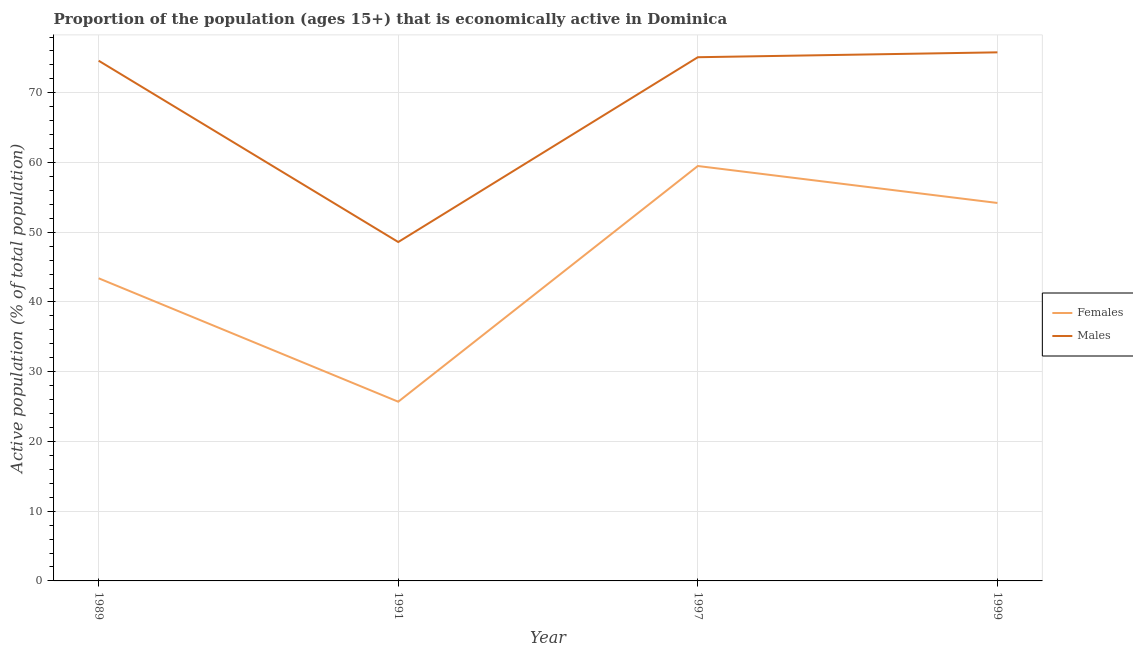How many different coloured lines are there?
Keep it short and to the point. 2. Is the number of lines equal to the number of legend labels?
Give a very brief answer. Yes. What is the percentage of economically active male population in 1999?
Your answer should be compact. 75.8. Across all years, what is the maximum percentage of economically active male population?
Provide a succinct answer. 75.8. Across all years, what is the minimum percentage of economically active male population?
Your response must be concise. 48.6. In which year was the percentage of economically active female population maximum?
Your answer should be compact. 1997. In which year was the percentage of economically active female population minimum?
Your answer should be compact. 1991. What is the total percentage of economically active male population in the graph?
Give a very brief answer. 274.1. What is the difference between the percentage of economically active female population in 1989 and that in 1991?
Provide a short and direct response. 17.7. What is the difference between the percentage of economically active male population in 1991 and the percentage of economically active female population in 1989?
Make the answer very short. 5.2. What is the average percentage of economically active female population per year?
Provide a short and direct response. 45.7. In the year 1989, what is the difference between the percentage of economically active female population and percentage of economically active male population?
Your response must be concise. -31.2. In how many years, is the percentage of economically active female population greater than 70 %?
Keep it short and to the point. 0. What is the ratio of the percentage of economically active male population in 1989 to that in 1991?
Your answer should be very brief. 1.53. What is the difference between the highest and the second highest percentage of economically active female population?
Give a very brief answer. 5.3. What is the difference between the highest and the lowest percentage of economically active female population?
Give a very brief answer. 33.8. Is the sum of the percentage of economically active female population in 1991 and 1997 greater than the maximum percentage of economically active male population across all years?
Provide a succinct answer. Yes. Does the percentage of economically active female population monotonically increase over the years?
Provide a succinct answer. No. How many lines are there?
Make the answer very short. 2. What is the difference between two consecutive major ticks on the Y-axis?
Your response must be concise. 10. Does the graph contain any zero values?
Provide a succinct answer. No. How are the legend labels stacked?
Provide a succinct answer. Vertical. What is the title of the graph?
Offer a terse response. Proportion of the population (ages 15+) that is economically active in Dominica. Does "Infant" appear as one of the legend labels in the graph?
Offer a terse response. No. What is the label or title of the Y-axis?
Your answer should be compact. Active population (% of total population). What is the Active population (% of total population) in Females in 1989?
Provide a succinct answer. 43.4. What is the Active population (% of total population) in Males in 1989?
Ensure brevity in your answer.  74.6. What is the Active population (% of total population) in Females in 1991?
Provide a succinct answer. 25.7. What is the Active population (% of total population) of Males in 1991?
Your answer should be very brief. 48.6. What is the Active population (% of total population) in Females in 1997?
Give a very brief answer. 59.5. What is the Active population (% of total population) of Males in 1997?
Your answer should be very brief. 75.1. What is the Active population (% of total population) in Females in 1999?
Your answer should be compact. 54.2. What is the Active population (% of total population) in Males in 1999?
Provide a succinct answer. 75.8. Across all years, what is the maximum Active population (% of total population) in Females?
Give a very brief answer. 59.5. Across all years, what is the maximum Active population (% of total population) in Males?
Offer a very short reply. 75.8. Across all years, what is the minimum Active population (% of total population) of Females?
Your answer should be compact. 25.7. Across all years, what is the minimum Active population (% of total population) in Males?
Make the answer very short. 48.6. What is the total Active population (% of total population) of Females in the graph?
Your response must be concise. 182.8. What is the total Active population (% of total population) in Males in the graph?
Offer a very short reply. 274.1. What is the difference between the Active population (% of total population) in Females in 1989 and that in 1997?
Give a very brief answer. -16.1. What is the difference between the Active population (% of total population) of Males in 1989 and that in 1999?
Your answer should be compact. -1.2. What is the difference between the Active population (% of total population) in Females in 1991 and that in 1997?
Your answer should be very brief. -33.8. What is the difference between the Active population (% of total population) of Males in 1991 and that in 1997?
Offer a terse response. -26.5. What is the difference between the Active population (% of total population) in Females in 1991 and that in 1999?
Your answer should be compact. -28.5. What is the difference between the Active population (% of total population) of Males in 1991 and that in 1999?
Give a very brief answer. -27.2. What is the difference between the Active population (% of total population) of Males in 1997 and that in 1999?
Your answer should be compact. -0.7. What is the difference between the Active population (% of total population) in Females in 1989 and the Active population (% of total population) in Males in 1991?
Offer a terse response. -5.2. What is the difference between the Active population (% of total population) of Females in 1989 and the Active population (% of total population) of Males in 1997?
Provide a succinct answer. -31.7. What is the difference between the Active population (% of total population) of Females in 1989 and the Active population (% of total population) of Males in 1999?
Your answer should be compact. -32.4. What is the difference between the Active population (% of total population) in Females in 1991 and the Active population (% of total population) in Males in 1997?
Your answer should be compact. -49.4. What is the difference between the Active population (% of total population) of Females in 1991 and the Active population (% of total population) of Males in 1999?
Offer a terse response. -50.1. What is the difference between the Active population (% of total population) in Females in 1997 and the Active population (% of total population) in Males in 1999?
Your answer should be very brief. -16.3. What is the average Active population (% of total population) in Females per year?
Offer a very short reply. 45.7. What is the average Active population (% of total population) of Males per year?
Provide a short and direct response. 68.53. In the year 1989, what is the difference between the Active population (% of total population) in Females and Active population (% of total population) in Males?
Make the answer very short. -31.2. In the year 1991, what is the difference between the Active population (% of total population) of Females and Active population (% of total population) of Males?
Your answer should be compact. -22.9. In the year 1997, what is the difference between the Active population (% of total population) of Females and Active population (% of total population) of Males?
Make the answer very short. -15.6. In the year 1999, what is the difference between the Active population (% of total population) in Females and Active population (% of total population) in Males?
Provide a succinct answer. -21.6. What is the ratio of the Active population (% of total population) of Females in 1989 to that in 1991?
Offer a very short reply. 1.69. What is the ratio of the Active population (% of total population) of Males in 1989 to that in 1991?
Give a very brief answer. 1.53. What is the ratio of the Active population (% of total population) of Females in 1989 to that in 1997?
Keep it short and to the point. 0.73. What is the ratio of the Active population (% of total population) of Males in 1989 to that in 1997?
Offer a terse response. 0.99. What is the ratio of the Active population (% of total population) of Females in 1989 to that in 1999?
Your response must be concise. 0.8. What is the ratio of the Active population (% of total population) in Males in 1989 to that in 1999?
Ensure brevity in your answer.  0.98. What is the ratio of the Active population (% of total population) in Females in 1991 to that in 1997?
Give a very brief answer. 0.43. What is the ratio of the Active population (% of total population) in Males in 1991 to that in 1997?
Your response must be concise. 0.65. What is the ratio of the Active population (% of total population) of Females in 1991 to that in 1999?
Your answer should be very brief. 0.47. What is the ratio of the Active population (% of total population) of Males in 1991 to that in 1999?
Your answer should be very brief. 0.64. What is the ratio of the Active population (% of total population) in Females in 1997 to that in 1999?
Give a very brief answer. 1.1. What is the difference between the highest and the second highest Active population (% of total population) of Females?
Provide a succinct answer. 5.3. What is the difference between the highest and the second highest Active population (% of total population) of Males?
Offer a terse response. 0.7. What is the difference between the highest and the lowest Active population (% of total population) in Females?
Your answer should be very brief. 33.8. What is the difference between the highest and the lowest Active population (% of total population) of Males?
Offer a very short reply. 27.2. 